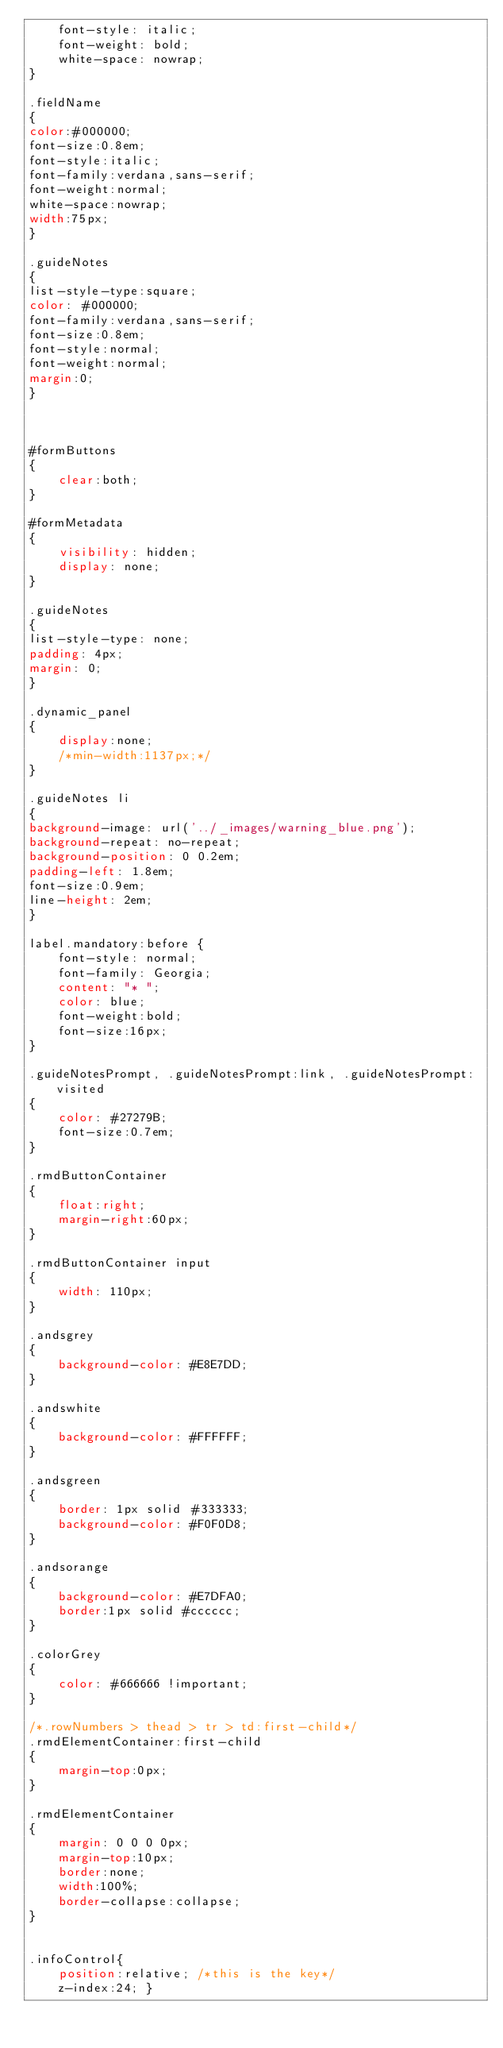Convert code to text. <code><loc_0><loc_0><loc_500><loc_500><_CSS_>	font-style: italic;
	font-weight: bold;
	white-space: nowrap;
}

.fieldName
{
color:#000000;
font-size:0.8em;
font-style:italic;
font-family:verdana,sans-serif;
font-weight:normal;
white-space:nowrap;
width:75px;
}

.guideNotes
{
list-style-type:square;
color: #000000;
font-family:verdana,sans-serif;
font-size:0.8em;
font-style:normal;
font-weight:normal;
margin:0;
}



#formButtons
{
	clear:both;
}

#formMetadata
{
	visibility: hidden;
	display: none;	
}

.guideNotes
{
list-style-type: none;
padding: 4px;
margin: 0;
}

.dynamic_panel 
{
	display:none;
	/*min-width:1137px;*/
}

.guideNotes li
{
background-image: url('../_images/warning_blue.png');
background-repeat: no-repeat;
background-position: 0 0.2em;
padding-left: 1.8em;
font-size:0.9em;
line-height: 2em;
}

label.mandatory:before {
	font-style: normal;
	font-family: Georgia;
	content: "* ";
	color: blue;
	font-weight:bold;
	font-size:16px;
}

.guideNotesPrompt, .guideNotesPrompt:link, .guideNotesPrompt:visited
{
	color: #27279B;
	font-size:0.7em;
}

.rmdButtonContainer
{
	float:right; 
	margin-right:60px;
}

.rmdButtonContainer input 
{
	width: 110px;	
}

.andsgrey
{
	background-color: #E8E7DD;	
}

.andswhite
{
	background-color: #FFFFFF;	
}

.andsgreen
{
	border: 1px solid #333333;
	background-color: #F0F0D8;	
}

.andsorange
{
	background-color: #E7DFA0;
	border:1px solid #cccccc;
}

.colorGrey 
{
	color: #666666 !important;	
}

/*.rowNumbers > thead > tr > td:first-child*/
.rmdElementContainer:first-child
{
	margin-top:0px;
}

.rmdElementContainer
{
	margin: 0 0 0 0px;
	margin-top:10px;
	border:none; 
	width:100%; 
	border-collapse:collapse;
}


.infoControl{
    position:relative; /*this is the key*/
    z-index:24; }
</code> 